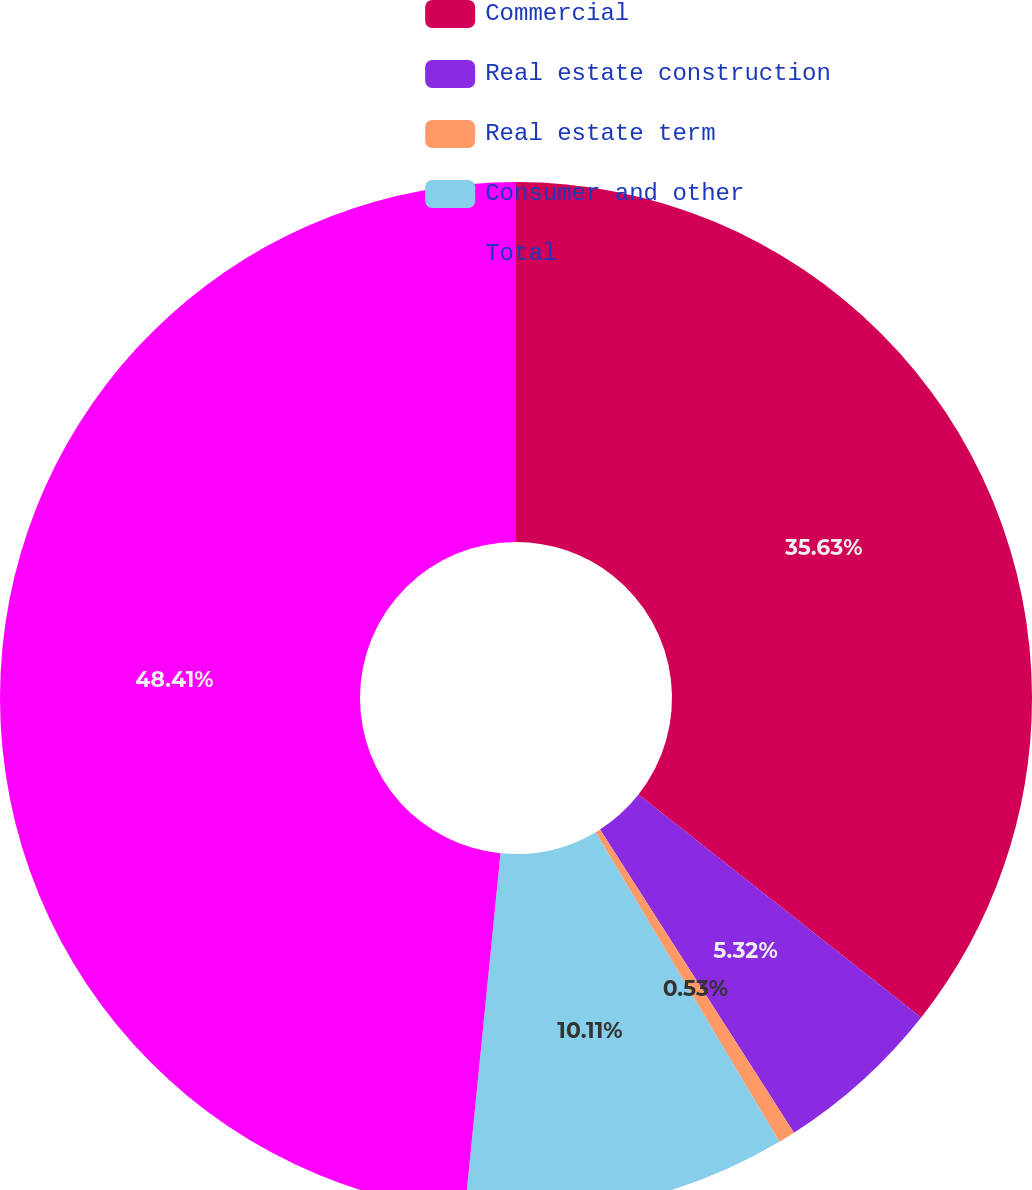Convert chart. <chart><loc_0><loc_0><loc_500><loc_500><pie_chart><fcel>Commercial<fcel>Real estate construction<fcel>Real estate term<fcel>Consumer and other<fcel>Total<nl><fcel>35.63%<fcel>5.32%<fcel>0.53%<fcel>10.11%<fcel>48.42%<nl></chart> 